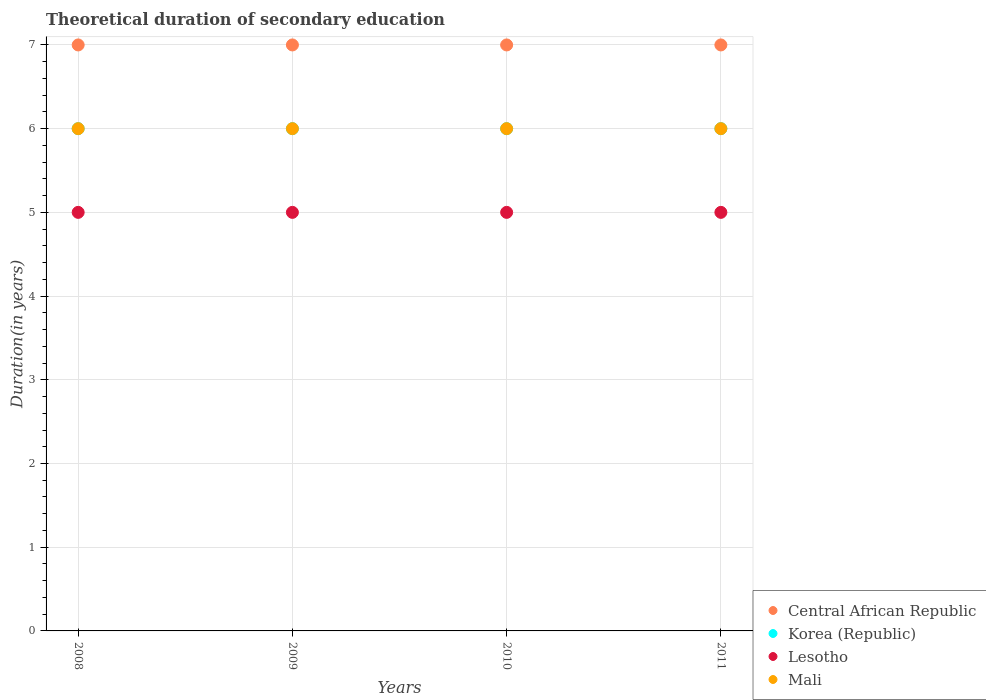How many different coloured dotlines are there?
Your answer should be very brief. 4. Is the number of dotlines equal to the number of legend labels?
Your answer should be compact. Yes. What is the total theoretical duration of secondary education in Central African Republic in 2009?
Make the answer very short. 7. Across all years, what is the maximum total theoretical duration of secondary education in Central African Republic?
Ensure brevity in your answer.  7. Across all years, what is the minimum total theoretical duration of secondary education in Central African Republic?
Keep it short and to the point. 7. In which year was the total theoretical duration of secondary education in Lesotho maximum?
Keep it short and to the point. 2008. In which year was the total theoretical duration of secondary education in Korea (Republic) minimum?
Your answer should be compact. 2008. What is the total total theoretical duration of secondary education in Mali in the graph?
Keep it short and to the point. 24. What is the difference between the total theoretical duration of secondary education in Mali in 2011 and the total theoretical duration of secondary education in Lesotho in 2008?
Give a very brief answer. 1. In the year 2010, what is the difference between the total theoretical duration of secondary education in Mali and total theoretical duration of secondary education in Korea (Republic)?
Make the answer very short. 0. Is the total theoretical duration of secondary education in Korea (Republic) in 2009 less than that in 2011?
Offer a terse response. No. Is the difference between the total theoretical duration of secondary education in Mali in 2008 and 2009 greater than the difference between the total theoretical duration of secondary education in Korea (Republic) in 2008 and 2009?
Your answer should be very brief. No. What is the difference between the highest and the second highest total theoretical duration of secondary education in Korea (Republic)?
Your answer should be compact. 0. Is the sum of the total theoretical duration of secondary education in Lesotho in 2009 and 2010 greater than the maximum total theoretical duration of secondary education in Korea (Republic) across all years?
Provide a short and direct response. Yes. Is it the case that in every year, the sum of the total theoretical duration of secondary education in Lesotho and total theoretical duration of secondary education in Mali  is greater than the sum of total theoretical duration of secondary education in Central African Republic and total theoretical duration of secondary education in Korea (Republic)?
Provide a succinct answer. No. Is it the case that in every year, the sum of the total theoretical duration of secondary education in Lesotho and total theoretical duration of secondary education in Korea (Republic)  is greater than the total theoretical duration of secondary education in Mali?
Provide a short and direct response. Yes. Does the total theoretical duration of secondary education in Lesotho monotonically increase over the years?
Keep it short and to the point. No. Is the total theoretical duration of secondary education in Mali strictly greater than the total theoretical duration of secondary education in Central African Republic over the years?
Provide a succinct answer. No. How many dotlines are there?
Offer a terse response. 4. How many years are there in the graph?
Ensure brevity in your answer.  4. Does the graph contain any zero values?
Give a very brief answer. No. How are the legend labels stacked?
Offer a terse response. Vertical. What is the title of the graph?
Ensure brevity in your answer.  Theoretical duration of secondary education. Does "OECD members" appear as one of the legend labels in the graph?
Keep it short and to the point. No. What is the label or title of the X-axis?
Keep it short and to the point. Years. What is the label or title of the Y-axis?
Your response must be concise. Duration(in years). What is the Duration(in years) in Lesotho in 2008?
Your answer should be very brief. 5. What is the Duration(in years) in Korea (Republic) in 2009?
Your response must be concise. 6. What is the Duration(in years) of Mali in 2009?
Make the answer very short. 6. What is the Duration(in years) of Mali in 2010?
Keep it short and to the point. 6. What is the Duration(in years) of Central African Republic in 2011?
Provide a succinct answer. 7. What is the Duration(in years) in Korea (Republic) in 2011?
Your answer should be very brief. 6. What is the Duration(in years) in Mali in 2011?
Ensure brevity in your answer.  6. Across all years, what is the maximum Duration(in years) of Central African Republic?
Keep it short and to the point. 7. Across all years, what is the maximum Duration(in years) of Korea (Republic)?
Your answer should be compact. 6. Across all years, what is the minimum Duration(in years) in Central African Republic?
Ensure brevity in your answer.  7. Across all years, what is the minimum Duration(in years) in Korea (Republic)?
Provide a succinct answer. 6. Across all years, what is the minimum Duration(in years) of Mali?
Make the answer very short. 6. What is the total Duration(in years) in Central African Republic in the graph?
Offer a very short reply. 28. What is the total Duration(in years) in Lesotho in the graph?
Provide a succinct answer. 20. What is the total Duration(in years) of Mali in the graph?
Provide a short and direct response. 24. What is the difference between the Duration(in years) in Korea (Republic) in 2008 and that in 2009?
Your answer should be compact. 0. What is the difference between the Duration(in years) in Lesotho in 2008 and that in 2010?
Offer a very short reply. 0. What is the difference between the Duration(in years) of Central African Republic in 2008 and that in 2011?
Provide a short and direct response. 0. What is the difference between the Duration(in years) in Central African Republic in 2009 and that in 2011?
Provide a succinct answer. 0. What is the difference between the Duration(in years) of Korea (Republic) in 2009 and that in 2011?
Offer a terse response. 0. What is the difference between the Duration(in years) in Lesotho in 2009 and that in 2011?
Your answer should be compact. 0. What is the difference between the Duration(in years) of Mali in 2009 and that in 2011?
Your response must be concise. 0. What is the difference between the Duration(in years) in Central African Republic in 2010 and that in 2011?
Provide a short and direct response. 0. What is the difference between the Duration(in years) of Korea (Republic) in 2010 and that in 2011?
Provide a succinct answer. 0. What is the difference between the Duration(in years) in Lesotho in 2010 and that in 2011?
Ensure brevity in your answer.  0. What is the difference between the Duration(in years) in Mali in 2010 and that in 2011?
Ensure brevity in your answer.  0. What is the difference between the Duration(in years) of Central African Republic in 2008 and the Duration(in years) of Korea (Republic) in 2009?
Your answer should be compact. 1. What is the difference between the Duration(in years) in Central African Republic in 2008 and the Duration(in years) in Lesotho in 2009?
Provide a short and direct response. 2. What is the difference between the Duration(in years) of Korea (Republic) in 2008 and the Duration(in years) of Lesotho in 2009?
Provide a short and direct response. 1. What is the difference between the Duration(in years) in Korea (Republic) in 2008 and the Duration(in years) in Mali in 2009?
Ensure brevity in your answer.  0. What is the difference between the Duration(in years) in Lesotho in 2008 and the Duration(in years) in Mali in 2009?
Offer a very short reply. -1. What is the difference between the Duration(in years) in Central African Republic in 2008 and the Duration(in years) in Korea (Republic) in 2010?
Keep it short and to the point. 1. What is the difference between the Duration(in years) in Korea (Republic) in 2008 and the Duration(in years) in Lesotho in 2010?
Your answer should be compact. 1. What is the difference between the Duration(in years) of Korea (Republic) in 2008 and the Duration(in years) of Mali in 2010?
Offer a terse response. 0. What is the difference between the Duration(in years) in Lesotho in 2008 and the Duration(in years) in Mali in 2010?
Provide a short and direct response. -1. What is the difference between the Duration(in years) in Central African Republic in 2008 and the Duration(in years) in Korea (Republic) in 2011?
Your answer should be very brief. 1. What is the difference between the Duration(in years) of Korea (Republic) in 2008 and the Duration(in years) of Mali in 2011?
Provide a succinct answer. 0. What is the difference between the Duration(in years) in Korea (Republic) in 2009 and the Duration(in years) in Mali in 2010?
Your answer should be very brief. 0. What is the difference between the Duration(in years) in Lesotho in 2009 and the Duration(in years) in Mali in 2010?
Provide a succinct answer. -1. What is the difference between the Duration(in years) in Central African Republic in 2009 and the Duration(in years) in Korea (Republic) in 2011?
Provide a short and direct response. 1. What is the difference between the Duration(in years) in Central African Republic in 2009 and the Duration(in years) in Mali in 2011?
Offer a terse response. 1. What is the difference between the Duration(in years) of Korea (Republic) in 2009 and the Duration(in years) of Mali in 2011?
Keep it short and to the point. 0. What is the difference between the Duration(in years) in Central African Republic in 2010 and the Duration(in years) in Korea (Republic) in 2011?
Make the answer very short. 1. What is the difference between the Duration(in years) of Central African Republic in 2010 and the Duration(in years) of Lesotho in 2011?
Ensure brevity in your answer.  2. What is the difference between the Duration(in years) of Korea (Republic) in 2010 and the Duration(in years) of Mali in 2011?
Keep it short and to the point. 0. What is the average Duration(in years) in Korea (Republic) per year?
Your answer should be very brief. 6. What is the average Duration(in years) of Lesotho per year?
Your response must be concise. 5. In the year 2008, what is the difference between the Duration(in years) of Central African Republic and Duration(in years) of Korea (Republic)?
Offer a terse response. 1. In the year 2008, what is the difference between the Duration(in years) of Central African Republic and Duration(in years) of Lesotho?
Your response must be concise. 2. In the year 2008, what is the difference between the Duration(in years) in Korea (Republic) and Duration(in years) in Lesotho?
Give a very brief answer. 1. In the year 2008, what is the difference between the Duration(in years) in Lesotho and Duration(in years) in Mali?
Your answer should be compact. -1. In the year 2009, what is the difference between the Duration(in years) of Korea (Republic) and Duration(in years) of Mali?
Your response must be concise. 0. In the year 2009, what is the difference between the Duration(in years) of Lesotho and Duration(in years) of Mali?
Give a very brief answer. -1. In the year 2010, what is the difference between the Duration(in years) of Central African Republic and Duration(in years) of Mali?
Your answer should be compact. 1. In the year 2010, what is the difference between the Duration(in years) of Korea (Republic) and Duration(in years) of Lesotho?
Provide a short and direct response. 1. In the year 2010, what is the difference between the Duration(in years) in Lesotho and Duration(in years) in Mali?
Your answer should be very brief. -1. In the year 2011, what is the difference between the Duration(in years) in Korea (Republic) and Duration(in years) in Lesotho?
Keep it short and to the point. 1. In the year 2011, what is the difference between the Duration(in years) of Korea (Republic) and Duration(in years) of Mali?
Provide a short and direct response. 0. In the year 2011, what is the difference between the Duration(in years) in Lesotho and Duration(in years) in Mali?
Your answer should be compact. -1. What is the ratio of the Duration(in years) of Central African Republic in 2008 to that in 2009?
Offer a terse response. 1. What is the ratio of the Duration(in years) in Lesotho in 2008 to that in 2009?
Give a very brief answer. 1. What is the ratio of the Duration(in years) in Korea (Republic) in 2008 to that in 2010?
Provide a succinct answer. 1. What is the ratio of the Duration(in years) of Lesotho in 2008 to that in 2010?
Make the answer very short. 1. What is the ratio of the Duration(in years) of Mali in 2008 to that in 2010?
Your answer should be compact. 1. What is the ratio of the Duration(in years) in Central African Republic in 2008 to that in 2011?
Offer a very short reply. 1. What is the ratio of the Duration(in years) of Mali in 2008 to that in 2011?
Provide a short and direct response. 1. What is the ratio of the Duration(in years) of Central African Republic in 2009 to that in 2010?
Your answer should be compact. 1. What is the ratio of the Duration(in years) in Korea (Republic) in 2009 to that in 2010?
Provide a short and direct response. 1. What is the ratio of the Duration(in years) in Lesotho in 2009 to that in 2010?
Offer a terse response. 1. What is the ratio of the Duration(in years) of Mali in 2009 to that in 2010?
Ensure brevity in your answer.  1. What is the ratio of the Duration(in years) of Central African Republic in 2009 to that in 2011?
Make the answer very short. 1. What is the ratio of the Duration(in years) in Lesotho in 2009 to that in 2011?
Ensure brevity in your answer.  1. What is the ratio of the Duration(in years) of Central African Republic in 2010 to that in 2011?
Your answer should be very brief. 1. What is the ratio of the Duration(in years) of Lesotho in 2010 to that in 2011?
Offer a terse response. 1. What is the ratio of the Duration(in years) of Mali in 2010 to that in 2011?
Your answer should be very brief. 1. What is the difference between the highest and the second highest Duration(in years) in Central African Republic?
Your response must be concise. 0. What is the difference between the highest and the second highest Duration(in years) of Mali?
Provide a succinct answer. 0. What is the difference between the highest and the lowest Duration(in years) of Korea (Republic)?
Make the answer very short. 0. 